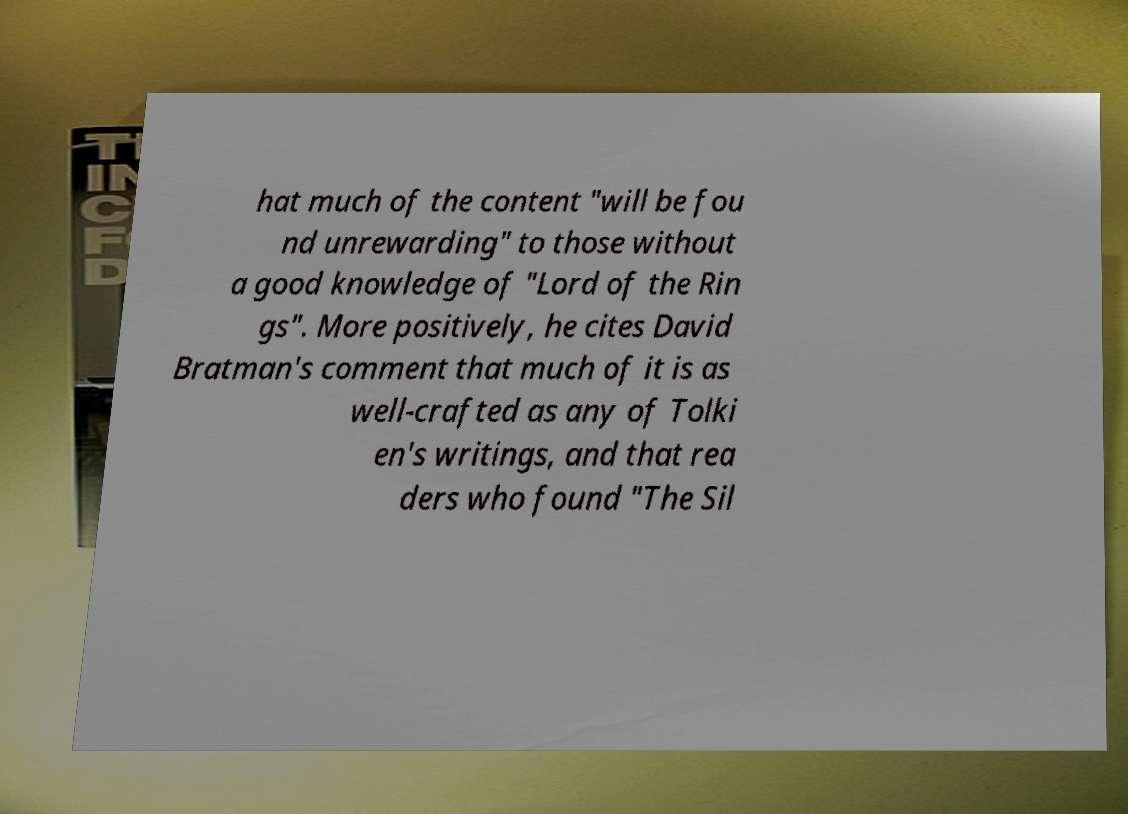Please read and relay the text visible in this image. What does it say? hat much of the content "will be fou nd unrewarding" to those without a good knowledge of "Lord of the Rin gs". More positively, he cites David Bratman's comment that much of it is as well-crafted as any of Tolki en's writings, and that rea ders who found "The Sil 